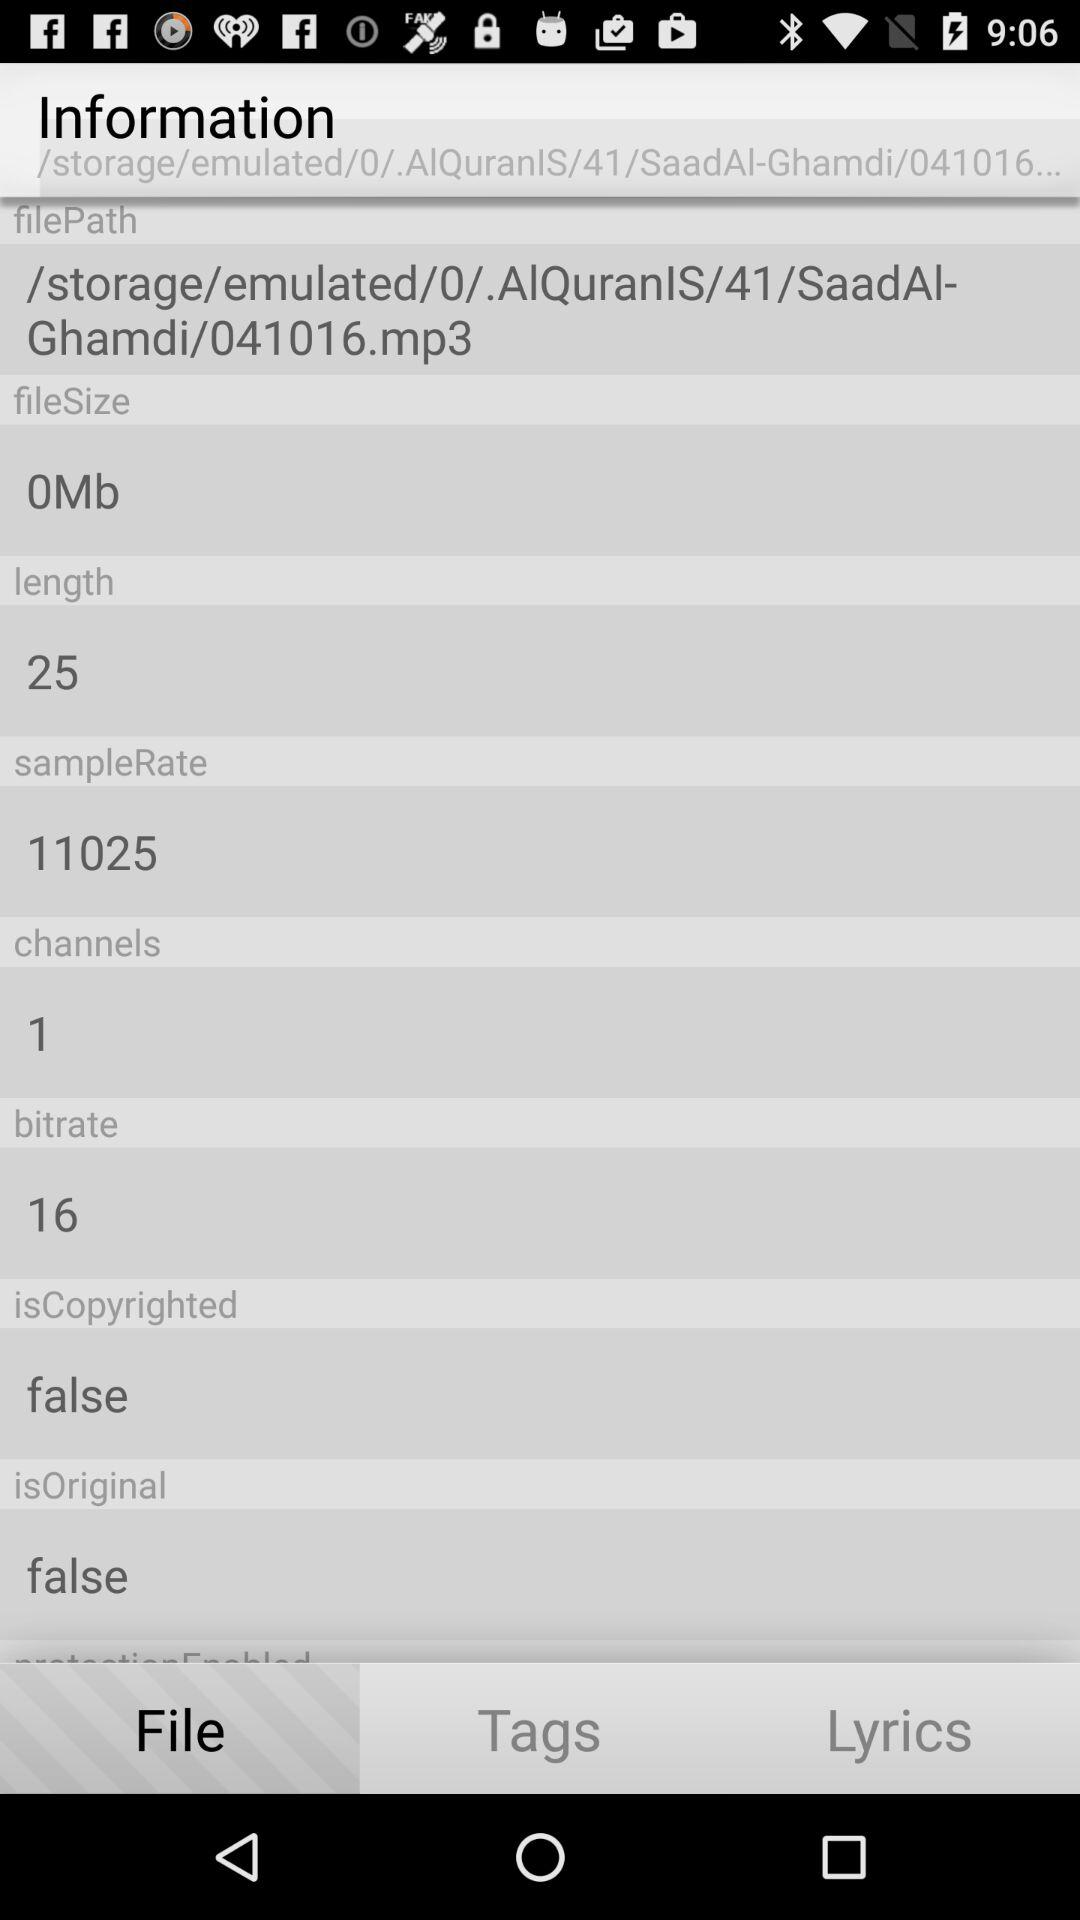What is the file size? The file size is 0 MB. 